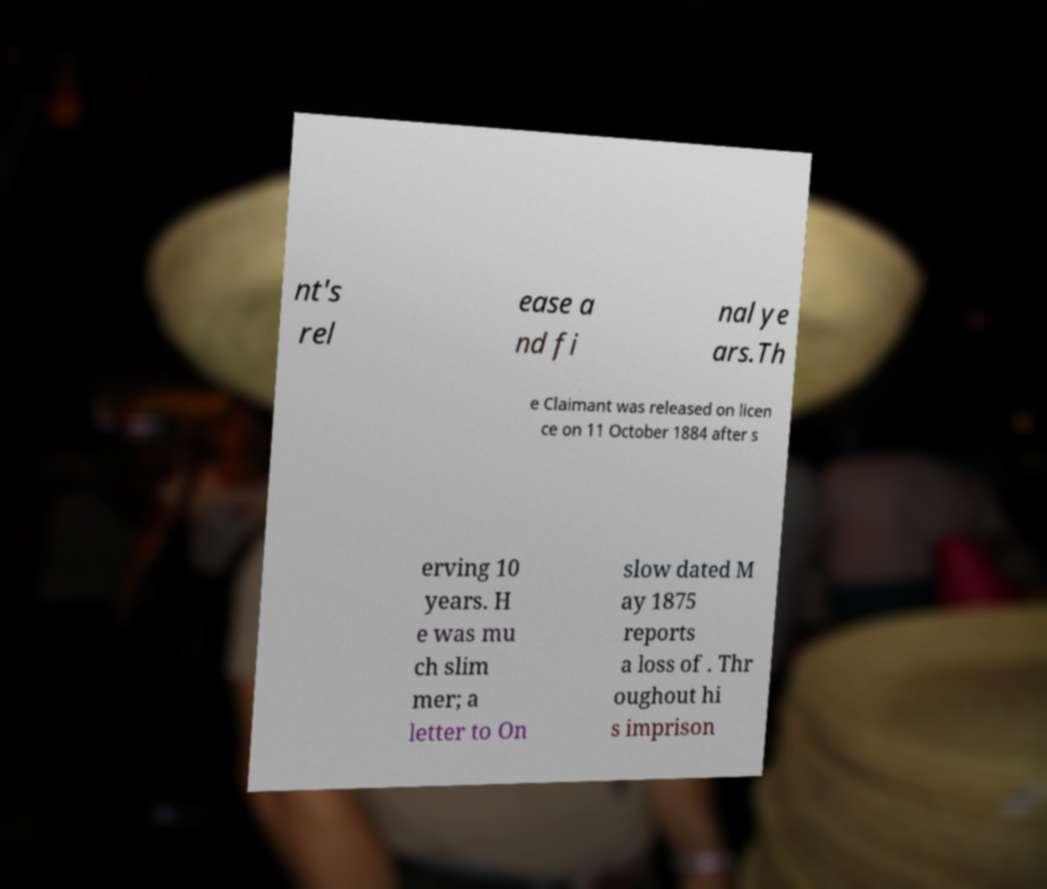Can you read and provide the text displayed in the image?This photo seems to have some interesting text. Can you extract and type it out for me? nt's rel ease a nd fi nal ye ars.Th e Claimant was released on licen ce on 11 October 1884 after s erving 10 years. H e was mu ch slim mer; a letter to On slow dated M ay 1875 reports a loss of . Thr oughout hi s imprison 